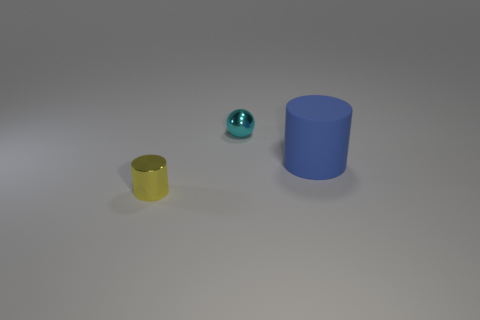Is the number of red rubber blocks greater than the number of big blue objects?
Your answer should be very brief. No. What is the size of the thing that is both to the left of the big blue cylinder and in front of the cyan sphere?
Your response must be concise. Small. There is a big matte object; what shape is it?
Offer a terse response. Cylinder. Is there any other thing that is the same size as the cyan object?
Keep it short and to the point. Yes. Are there more metal objects that are left of the tiny cyan thing than tiny gray matte cylinders?
Give a very brief answer. Yes. The tiny metallic thing in front of the cylinder that is to the right of the tiny thing on the left side of the metal ball is what shape?
Give a very brief answer. Cylinder. There is a cylinder that is right of the cyan metal ball; does it have the same size as the shiny cylinder?
Ensure brevity in your answer.  No. What is the shape of the thing that is to the right of the small yellow metallic cylinder and left of the big cylinder?
Your answer should be very brief. Sphere. Does the small metal ball have the same color as the cylinder behind the tiny shiny cylinder?
Offer a terse response. No. The thing that is left of the tiny metallic object behind the blue thing that is right of the cyan sphere is what color?
Provide a short and direct response. Yellow. 